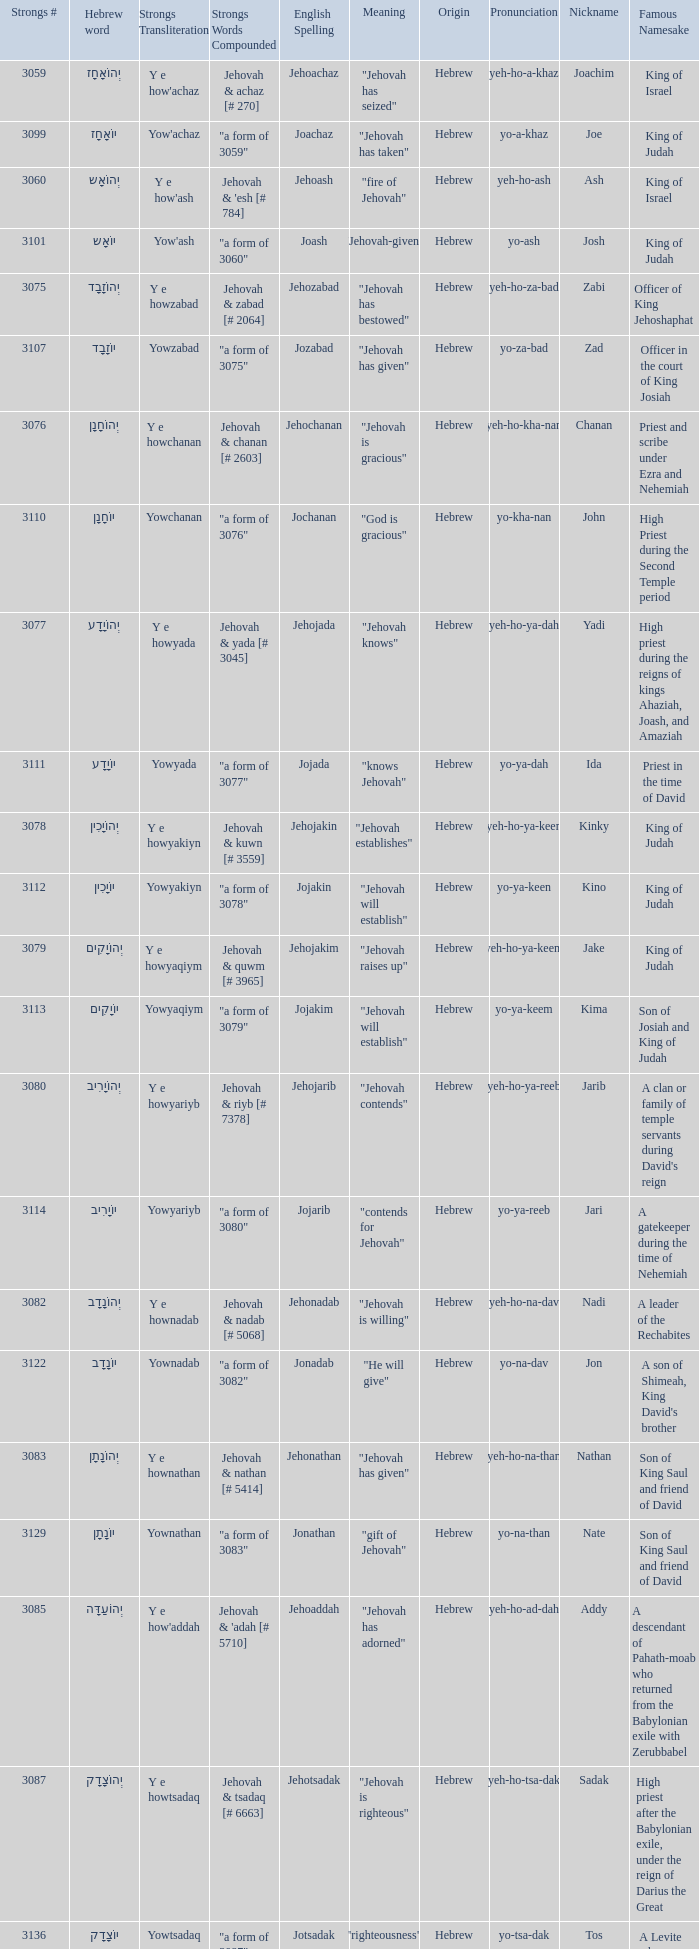What are the most powerful words that can be formed by combining the english spelling of "jonadab"? "a form of 3082". 